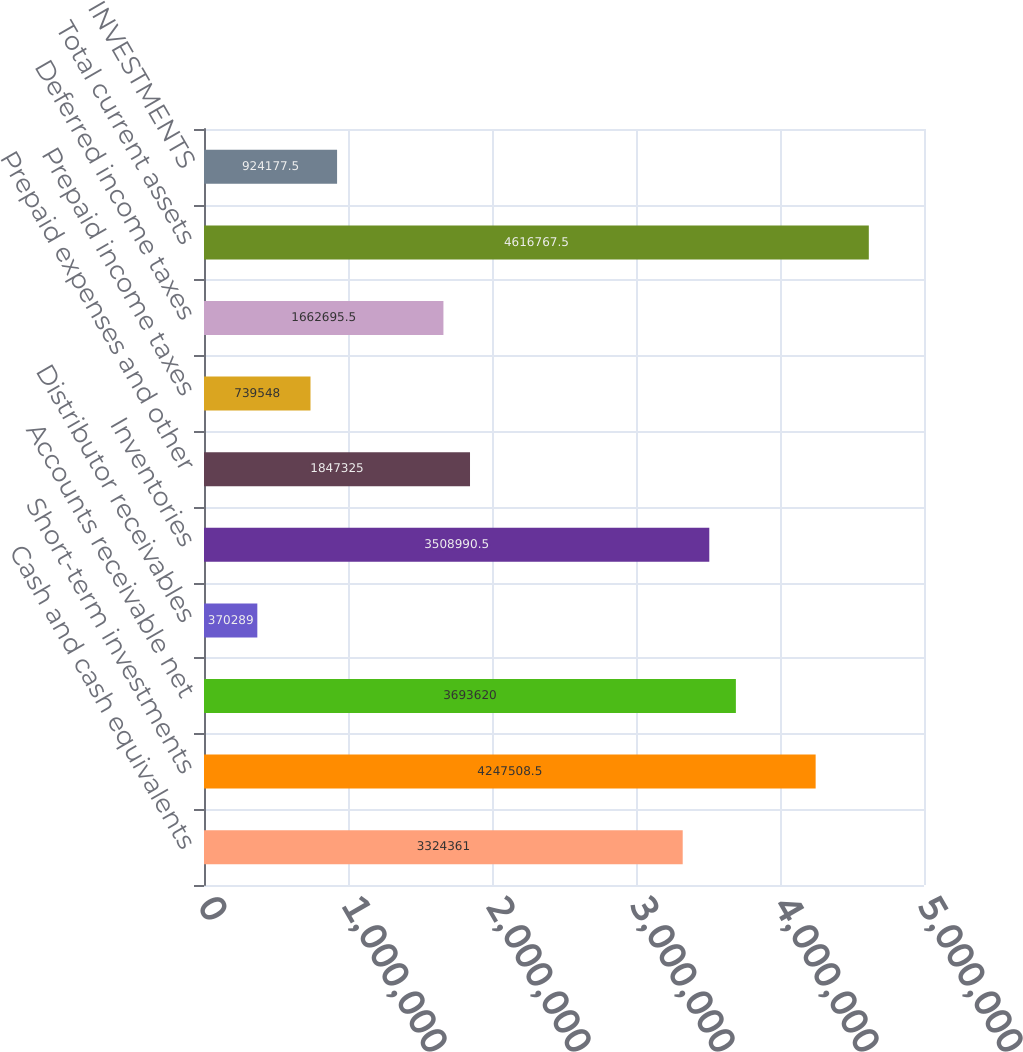Convert chart. <chart><loc_0><loc_0><loc_500><loc_500><bar_chart><fcel>Cash and cash equivalents<fcel>Short-term investments<fcel>Accounts receivable net<fcel>Distributor receivables<fcel>Inventories<fcel>Prepaid expenses and other<fcel>Prepaid income taxes<fcel>Deferred income taxes<fcel>Total current assets<fcel>INVESTMENTS<nl><fcel>3.32436e+06<fcel>4.24751e+06<fcel>3.69362e+06<fcel>370289<fcel>3.50899e+06<fcel>1.84732e+06<fcel>739548<fcel>1.6627e+06<fcel>4.61677e+06<fcel>924178<nl></chart> 